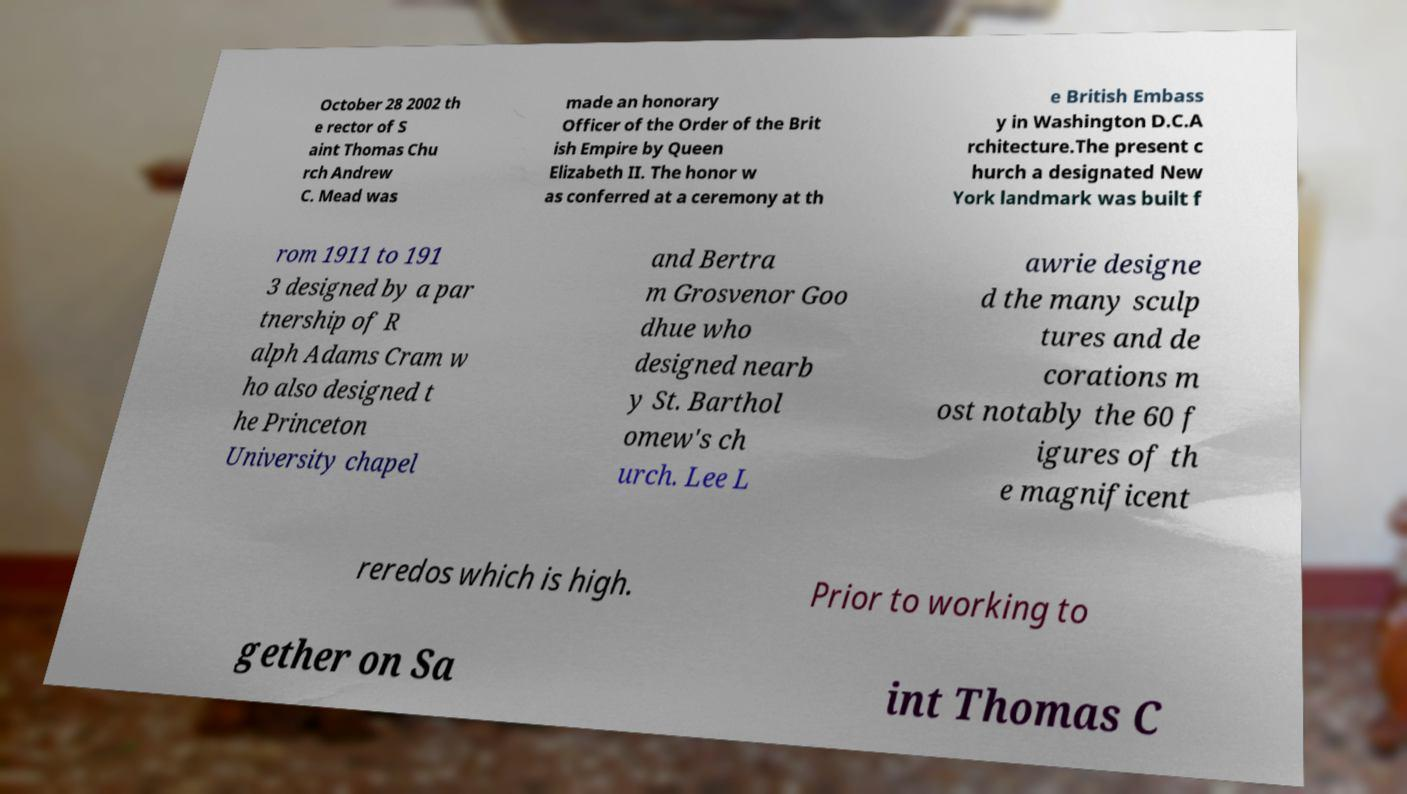There's text embedded in this image that I need extracted. Can you transcribe it verbatim? October 28 2002 th e rector of S aint Thomas Chu rch Andrew C. Mead was made an honorary Officer of the Order of the Brit ish Empire by Queen Elizabeth II. The honor w as conferred at a ceremony at th e British Embass y in Washington D.C.A rchitecture.The present c hurch a designated New York landmark was built f rom 1911 to 191 3 designed by a par tnership of R alph Adams Cram w ho also designed t he Princeton University chapel and Bertra m Grosvenor Goo dhue who designed nearb y St. Barthol omew's ch urch. Lee L awrie designe d the many sculp tures and de corations m ost notably the 60 f igures of th e magnificent reredos which is high. Prior to working to gether on Sa int Thomas C 